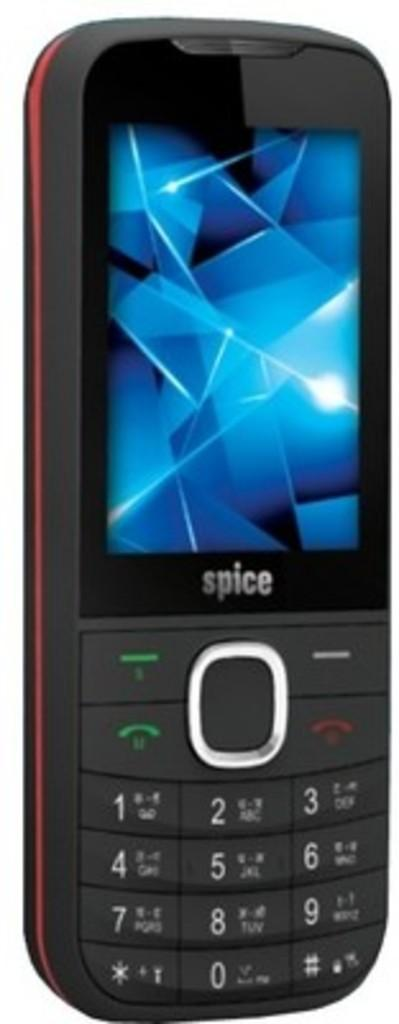<image>
Create a compact narrative representing the image presented. A cell phone with a number that has the digits 0 through 9. 